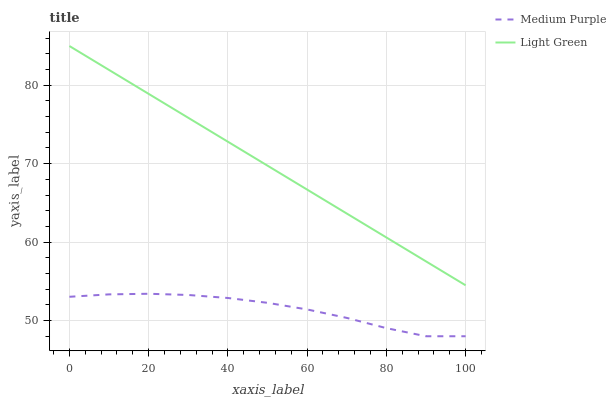Does Medium Purple have the minimum area under the curve?
Answer yes or no. Yes. Does Light Green have the maximum area under the curve?
Answer yes or no. Yes. Does Light Green have the minimum area under the curve?
Answer yes or no. No. Is Light Green the smoothest?
Answer yes or no. Yes. Is Medium Purple the roughest?
Answer yes or no. Yes. Is Light Green the roughest?
Answer yes or no. No. Does Medium Purple have the lowest value?
Answer yes or no. Yes. Does Light Green have the lowest value?
Answer yes or no. No. Does Light Green have the highest value?
Answer yes or no. Yes. Is Medium Purple less than Light Green?
Answer yes or no. Yes. Is Light Green greater than Medium Purple?
Answer yes or no. Yes. Does Medium Purple intersect Light Green?
Answer yes or no. No. 